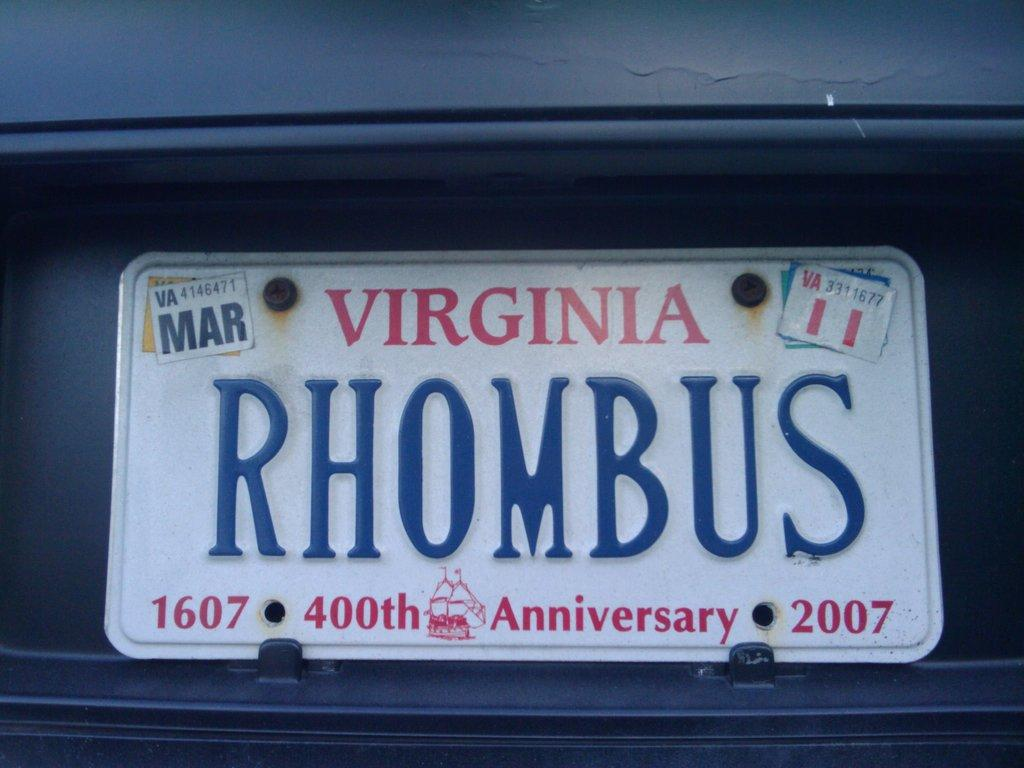<image>
Offer a succinct explanation of the picture presented. A 400th anniversary 2007 Virginia license plate says "RHOMBUS" 